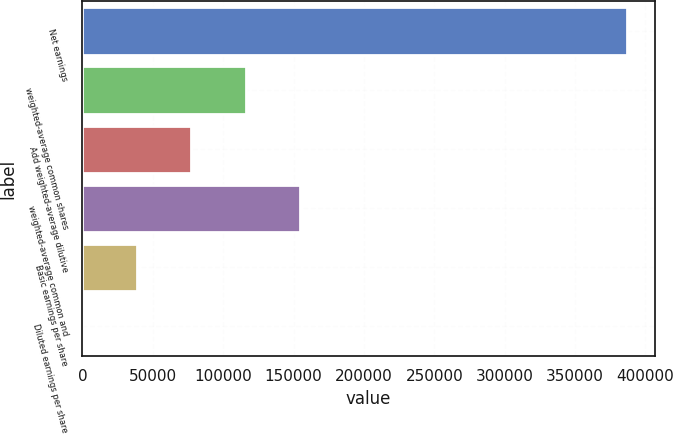Convert chart to OTSL. <chart><loc_0><loc_0><loc_500><loc_500><bar_chart><fcel>Net earnings<fcel>weighted-average common shares<fcel>Add weighted-average dilutive<fcel>weighted-average common and<fcel>Basic earnings per share<fcel>Diluted earnings per share<nl><fcel>387138<fcel>116145<fcel>77432.2<fcel>154859<fcel>38718.9<fcel>5.72<nl></chart> 